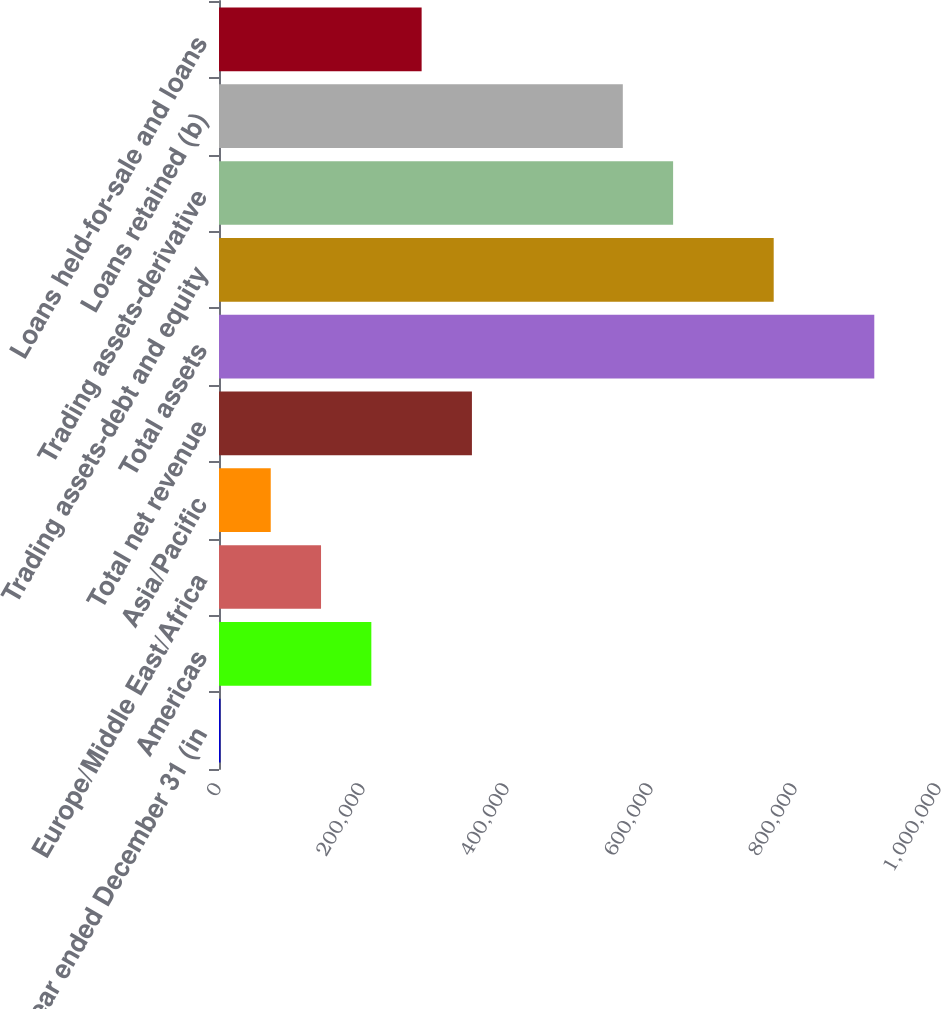Convert chart to OTSL. <chart><loc_0><loc_0><loc_500><loc_500><bar_chart><fcel>Year ended December 31 (in<fcel>Americas<fcel>Europe/Middle East/Africa<fcel>Asia/Pacific<fcel>Total net revenue<fcel>Total assets<fcel>Trading assets-debt and equity<fcel>Trading assets-derivative<fcel>Loans retained (b)<fcel>Loans held-for-sale and loans<nl><fcel>2007<fcel>211574<fcel>141719<fcel>71862.8<fcel>351286<fcel>910132<fcel>770421<fcel>630709<fcel>560853<fcel>281430<nl></chart> 